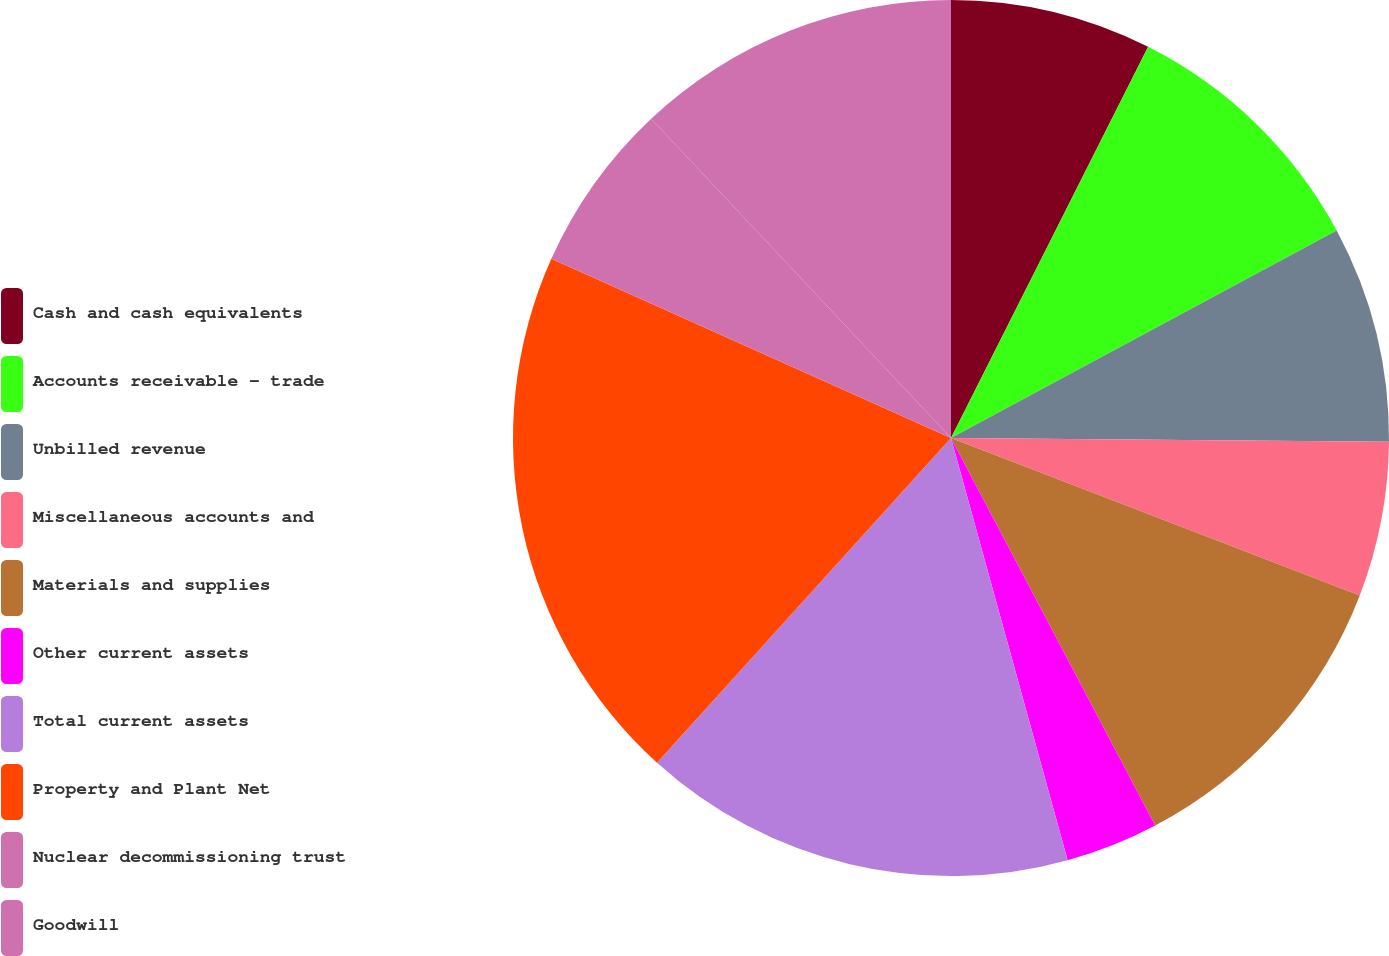Convert chart. <chart><loc_0><loc_0><loc_500><loc_500><pie_chart><fcel>Cash and cash equivalents<fcel>Accounts receivable - trade<fcel>Unbilled revenue<fcel>Miscellaneous accounts and<fcel>Materials and supplies<fcel>Other current assets<fcel>Total current assets<fcel>Property and Plant Net<fcel>Nuclear decommissioning trust<fcel>Goodwill<nl><fcel>7.43%<fcel>9.71%<fcel>8.0%<fcel>5.71%<fcel>11.43%<fcel>3.43%<fcel>16.0%<fcel>20.0%<fcel>6.29%<fcel>12.0%<nl></chart> 